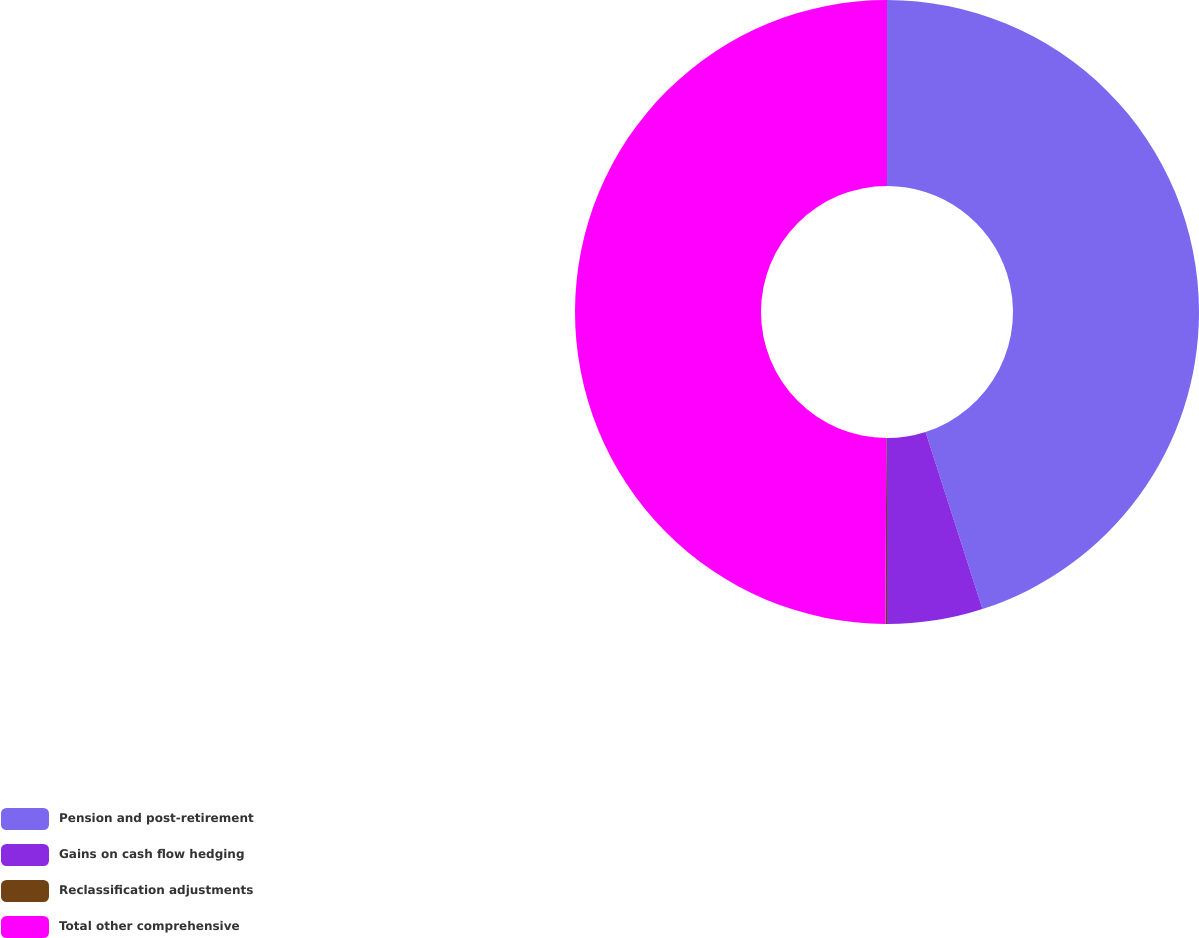Convert chart. <chart><loc_0><loc_0><loc_500><loc_500><pie_chart><fcel>Pension and post-retirement<fcel>Gains on cash flow hedging<fcel>Reclassification adjustments<fcel>Total other comprehensive<nl><fcel>45.05%<fcel>4.95%<fcel>0.08%<fcel>49.92%<nl></chart> 